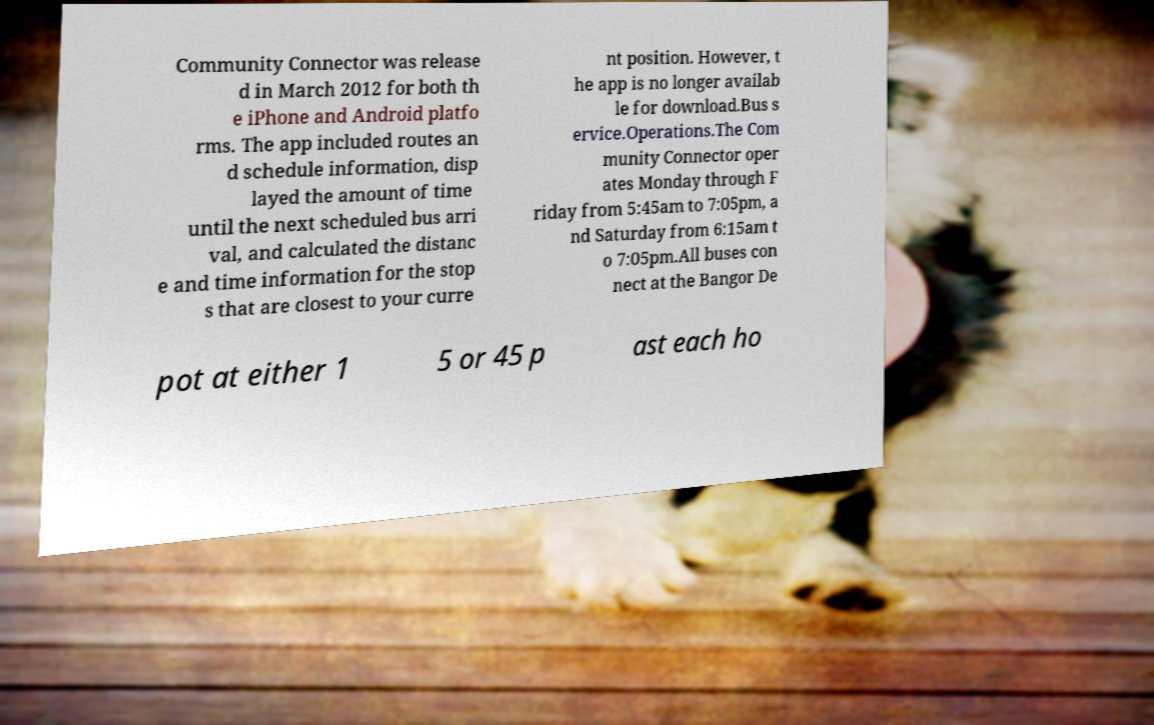For documentation purposes, I need the text within this image transcribed. Could you provide that? Community Connector was release d in March 2012 for both th e iPhone and Android platfo rms. The app included routes an d schedule information, disp layed the amount of time until the next scheduled bus arri val, and calculated the distanc e and time information for the stop s that are closest to your curre nt position. However, t he app is no longer availab le for download.Bus s ervice.Operations.The Com munity Connector oper ates Monday through F riday from 5:45am to 7:05pm, a nd Saturday from 6:15am t o 7:05pm.All buses con nect at the Bangor De pot at either 1 5 or 45 p ast each ho 